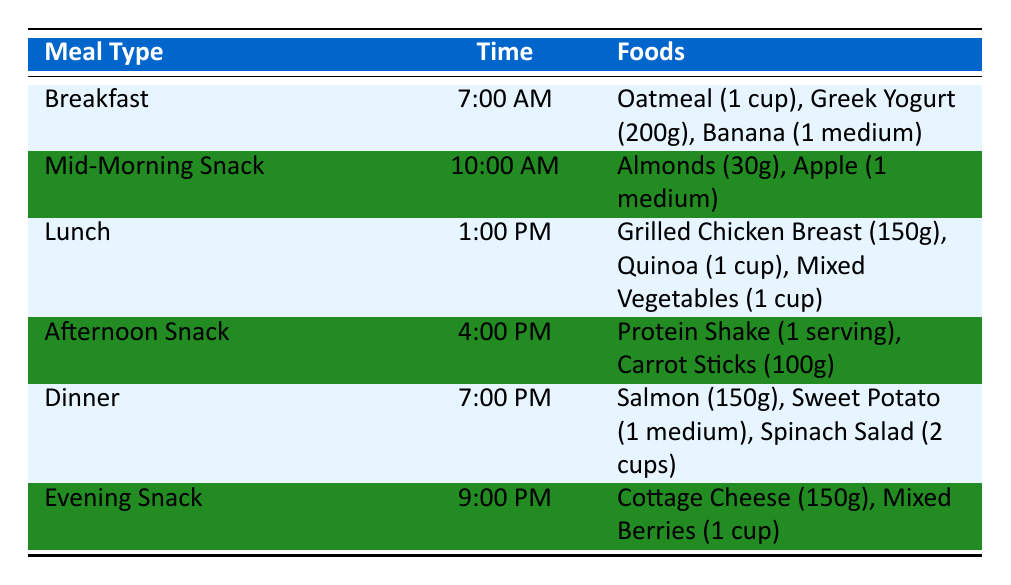What time is lunch scheduled? The table lists the meal types along with their corresponding times. By searching for "Lunch" in the table, we find that it is scheduled at "1:00 PM."
Answer: 1:00 PM How many grams of Greek Yogurt are included in breakfast? Looking at the "Breakfast" entry, we can see that "Greek Yogurt" is listed with a quantity of "200 grams."
Answer: 200 grams Which meal includes almonds, and what is their quantity? By checking the "Mid-Morning Snack" section of the table, almonds are included, and their quantity is "30 grams."
Answer: Mid-Morning Snack, 30 grams What is the total calorie count for the Afternoon Snack? For the "Afternoon Snack," we can find the calories for each food item: "Protein Shake" has 120 calories and "Carrot Sticks" has 41 calories. The total is 120 + 41 = 161.
Answer: 161 calories Does dinner include any carbohydrates? By inspecting the "Dinner" section, we notice that the foods listed are "Salmon" (0g carbs), "Sweet Potato" (26g carbs), and "Spinach Salad" (2g carbs). Since there is a non-zero quantity of carbohydrates in Sweet Potato and Spinach Salad, the answer is yes.
Answer: Yes What is the average amount of protein in a day's meals? To find the average protein for the day, we first need to sum the protein amounts from each meal: Breakfast (29g), Mid-Morning Snack (6g), Lunch (42g), Afternoon Snack (25g), Dinner (41g), and Evening Snack (29g). The total is 29 + 6 + 42 + 25 + 41 + 29 = 172g. There are 6 meals, so the average is 172/6 = about 28.67g.
Answer: Approximately 28.67 grams Is the total fat content for breakfast more than 10 grams? Analyzing the "Breakfast" section, the fats are: Oatmeal (3g), Greek Yogurt (0g), and Banana (0g), totaling 3 grams. Since 3 grams is less than 10 grams, the answer is no.
Answer: No What is the meal type that contains protein shake, and what is its calorie content? The protein shake is listed under the "Afternoon Snack," where its calorie content is specified as "120 calories."
Answer: Afternoon Snack, 120 calories How many total servings of vegetables are in the lunch meal? The lunch meal includes "Mixed Vegetables" with a quantity of "1 cup." Therefore, the total servings of vegetables in lunch is 1 cup, as there are no other vegetable servings listed for that meal.
Answer: 1 cup 